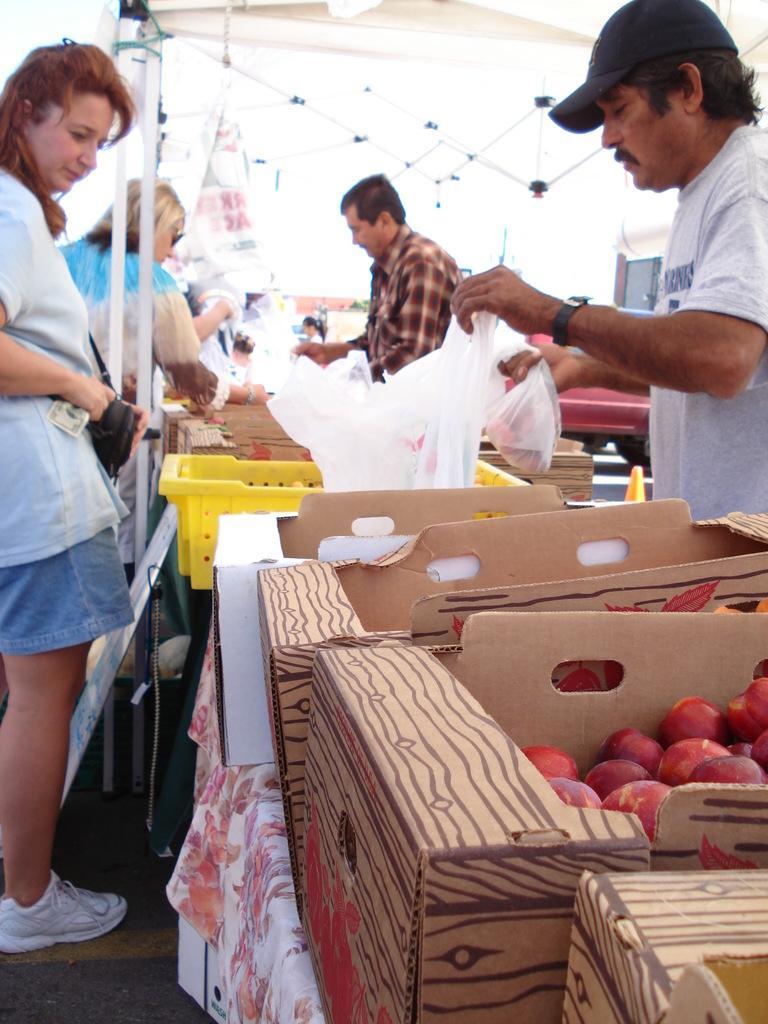Describe this image in one or two sentences. In this image there are boxes of apples in the middle and there are sellers on the right side who are selling the apples by keeping it in the cover. On the left side there are two women who are looking at the apples. At the top there is tent. 